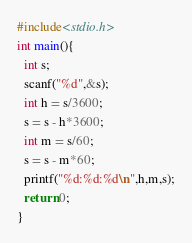Convert code to text. <code><loc_0><loc_0><loc_500><loc_500><_C_>#include<stdio.h>
int main(){
  int s;
  scanf("%d",&s);
  int h = s/3600;
  s = s - h*3600;
  int m = s/60;
  s = s - m*60;
  printf("%d:%d:%d\n",h,m,s);
  return 0;
}</code> 